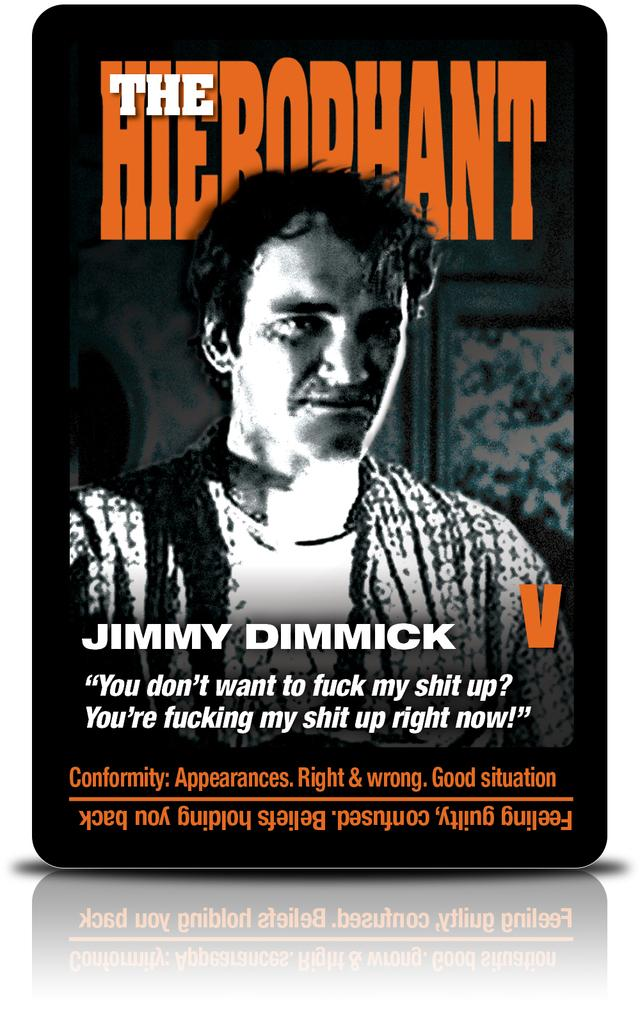What is the main subject of the picture? There is an image of a person in the picture. What is written above the image? There is text written above the image. What is written below the image? There is text written below the image. How does the person compare to their friends in the image? There is no information about friends in the image, so it's not possible to make a comparison. 